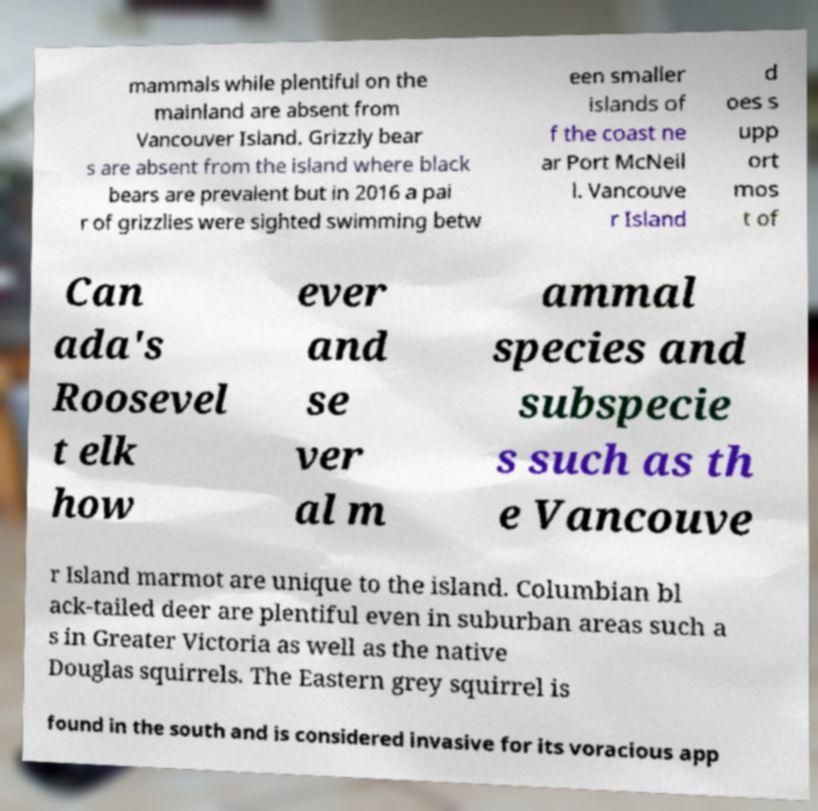Please identify and transcribe the text found in this image. mammals while plentiful on the mainland are absent from Vancouver Island. Grizzly bear s are absent from the island where black bears are prevalent but in 2016 a pai r of grizzlies were sighted swimming betw een smaller islands of f the coast ne ar Port McNeil l. Vancouve r Island d oes s upp ort mos t of Can ada's Roosevel t elk how ever and se ver al m ammal species and subspecie s such as th e Vancouve r Island marmot are unique to the island. Columbian bl ack-tailed deer are plentiful even in suburban areas such a s in Greater Victoria as well as the native Douglas squirrels. The Eastern grey squirrel is found in the south and is considered invasive for its voracious app 